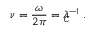Convert formula to latex. <formula><loc_0><loc_0><loc_500><loc_500>\nu = \frac { \omega } { 2 \pi } = \lambda _ { \, C } ^ { - 1 } \, .</formula> 